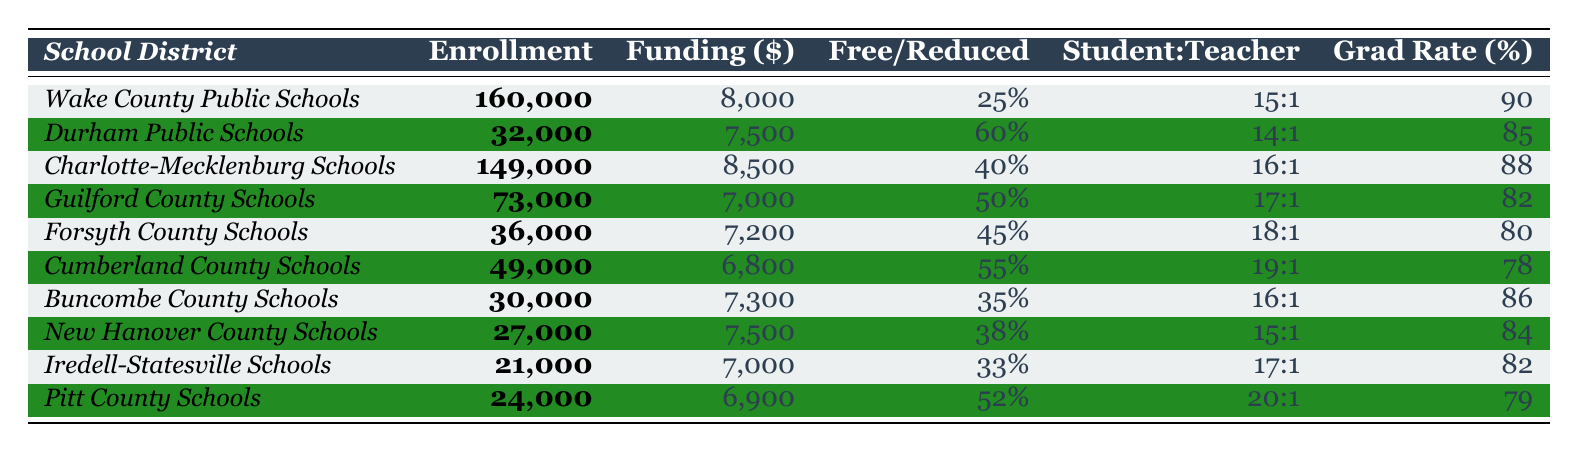What is the total enrollment in Wake County Public Schools? The table shows that Wake County Public Schools has a total enrollment of 160,000 students listed in the second column under "Enrollment."
Answer: 160,000 Which school district has the highest per-student funding? By reviewing the "Funding" column, Charlotte-Mecklenburg Schools has the highest per-student funding at $8,500.
Answer: Charlotte-Mecklenburg Schools What is the average graduation rate across all listed school districts? To find the average graduation rate, add the graduation rates: (90 + 85 + 88 + 82 + 80 + 78 + 86 + 84 + 82 + 79) = 843. Then divide by the number of districts, which is 10: 843 / 10 = 84.3%.
Answer: 84.3% Does Guilford County Schools have a higher percentage of students on free and reduced lunch than Durham Public Schools? Guilford County Schools has 50% on free and reduced lunch, while Durham Public Schools has 60%. Since 50% is not higher than 60%, the answer is no.
Answer: No What is the total funding for the Durham Public Schools? The funding for Durham Public Schools is listed as $7,500 per student, and the total enrollment is 32,000 students. Therefore, total funding is calculated as 32,000 * 7,500 = $240,000,000.
Answer: $240,000,000 Which school district has the highest student-teacher ratio? The student-teacher ratios listed are: Wake County (15:1), Durham (14:1), Charlotte-Mecklenburg (16:1), Guilford (17:1), Forsyth (18:1), Cumberland (19:1), Buncombe (16:1), New Hanover (15:1), Iredell-Statesville (17:1), and Pitt (20:1). The highest is Pitt County Schools at 20:1.
Answer: Pitt County Schools Can we conclude that higher per-student funding correlates with a higher graduation rate? Analyzing the data indicates that Wake County (8,000 funding, 90% graduation) and Durham (7,500 funding, 85% graduation) seem to show a trend, but other districts (e.g., Cumberland at 6,800 funding, 78% graduation) show lower rates with lower funding. Thus, we cannot definitively conclude a correlation.
Answer: No What is the difference in per-student funding between Wake County Public Schools and Cumberland County Schools? The per-student funding for Wake County is $8,000 and for Cumberland is $6,800. The difference is 8,000 - 6,800 = 1,200.
Answer: $1,200 How does the average percentage of free and reduced lunch students compare to that of the graduation rates across districts? The average percentage of free and reduced lunch students is calculated as follows: (25 + 60 + 40 + 50 + 45 + 55 + 35 + 38 + 33 + 52) = 433, and dividing by 10 gives 43.3%. The average graduation rate was found to be 84.3%. Therefore, the graduation rate is higher than the average percentage of free and reduced lunch students.
Answer: Higher Is the total enrollment in Charlotte-Mecklenburg Schools greater than that in Buncombe County Schools? Charlotte-Mecklenburg Schools has an enrollment of 149,000 while Buncombe County Schools has 30,000. 149,000 is greater than 30,000.
Answer: Yes 